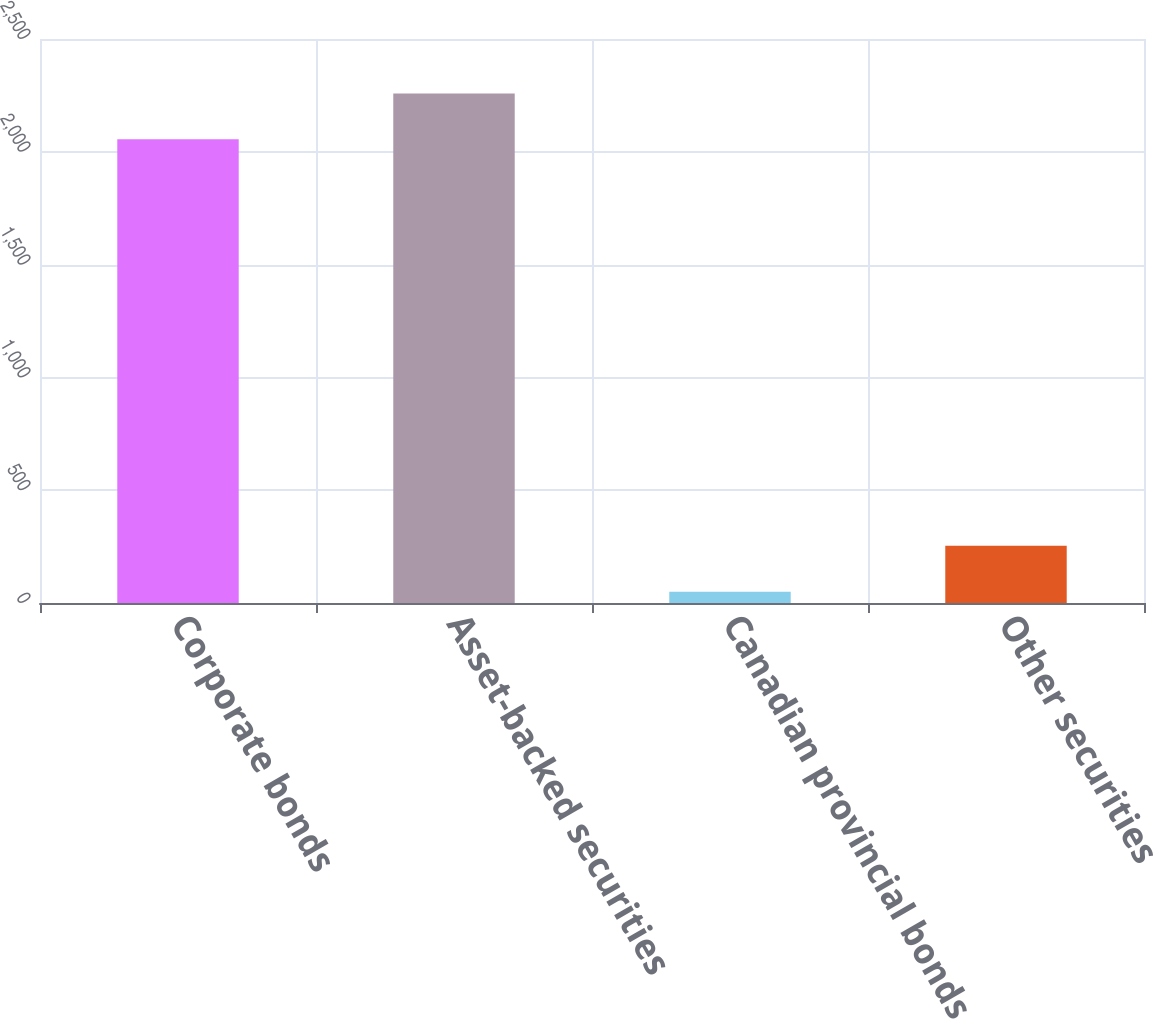Convert chart. <chart><loc_0><loc_0><loc_500><loc_500><bar_chart><fcel>Corporate bonds<fcel>Asset-backed securities<fcel>Canadian provincial bonds<fcel>Other securities<nl><fcel>2055.6<fcel>2258.94<fcel>50.1<fcel>253.44<nl></chart> 